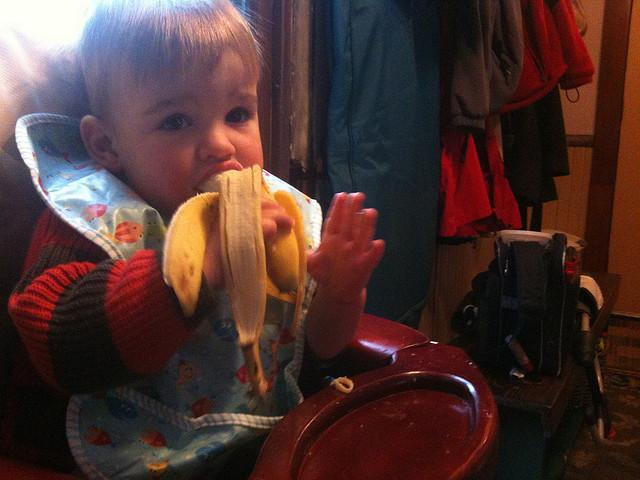Why is he wearing a bib?

Choices:
A) helps sleep
B) store things
C) protect clothing
D) stylish protect clothing 